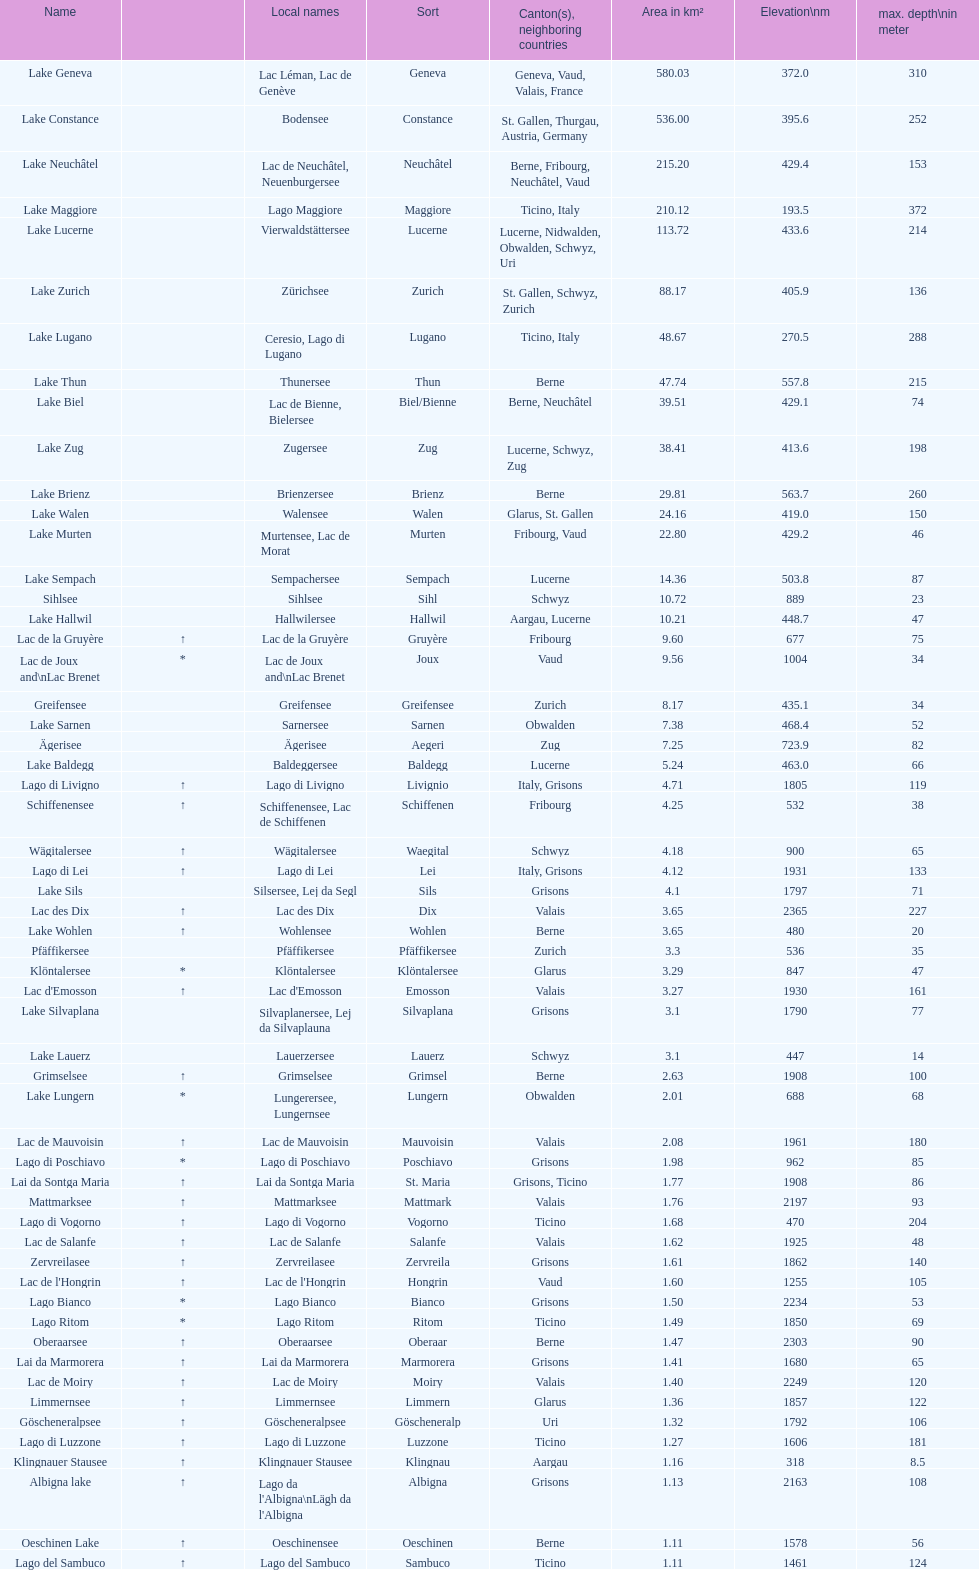Which lake has an area equal to or greater than 580 km²? Lake Geneva. 